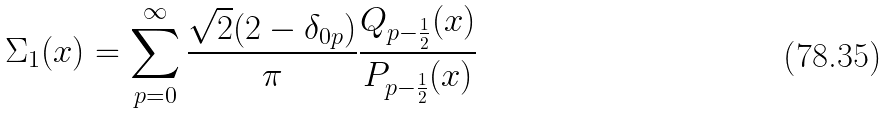Convert formula to latex. <formula><loc_0><loc_0><loc_500><loc_500>\Sigma _ { 1 } ( x ) = \sum _ { p = 0 } ^ { \infty } \frac { \sqrt { 2 } ( 2 - \delta _ { 0 p } ) } { \pi } \frac { Q _ { p - \frac { 1 } { 2 } } ( x ) } { P _ { p - \frac { 1 } { 2 } } ( x ) }</formula> 